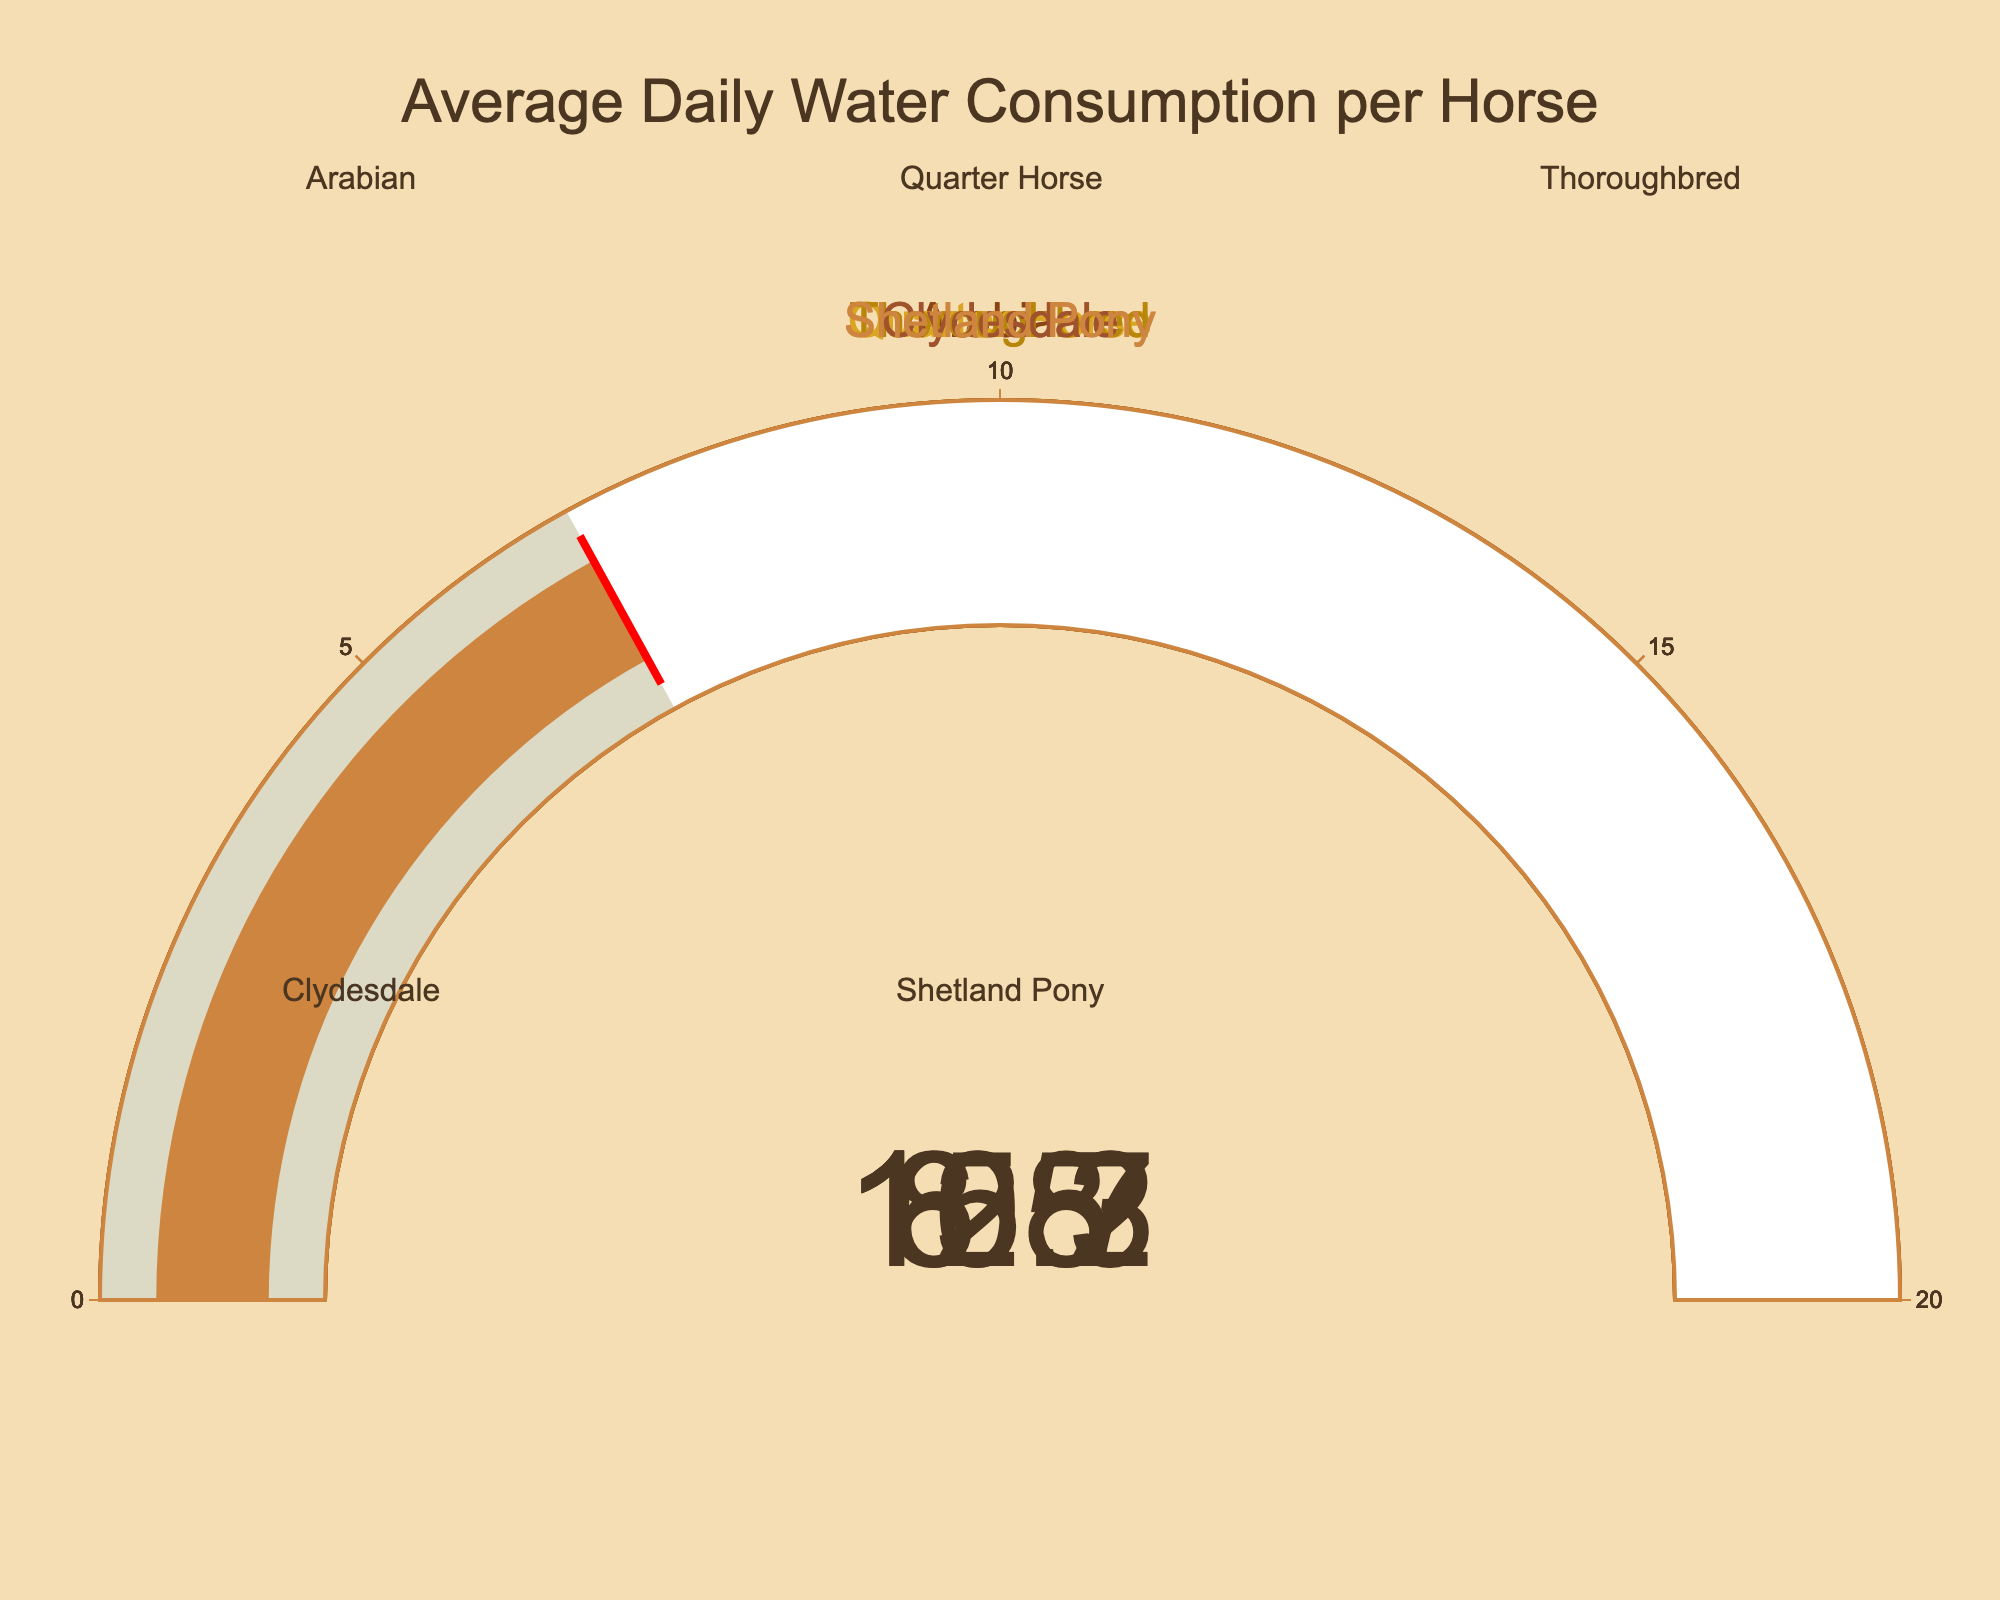What is the title of the figure? The title is displayed at the top of the figure. It reads "Average Daily Water Consumption per Horse".
Answer: Average Daily Water Consumption per Horse How many types of horses are represented? There are 5 dials on the figure, each representing a different type of horse: Arabian, Quarter Horse, Thoroughbred, Clydesdale, and Shetland Pony.
Answer: 5 What is the average daily water consumption for an Arabian horse? Looking at the dial corresponding to the Arabian horse, it shows a consumption value of 8.5 gallons.
Answer: 8.5 gallons Which horse has the highest average daily water consumption? The figure displays different water consumption levels for each horse. The higher value is 15.3 gallons, associated with the Clydesdale.
Answer: Clydesdale What is the total average daily water consumption of all the horses combined? To find the total, sum the individual consumptions: 8.5 + 10.2 + 12.7 + 15.3 + 6.8 = 53.5 gallons.
Answer: 53.5 gallons Which horse consumes more water daily, the Quarter Horse or the Shetland Pony? Comparing the dials, the Quarter Horse shows 10.2 gallons, while the Shetland Pony shows 6.8 gallons. The Quarter Horse consumes more.
Answer: Quarter Horse What is the range of water consumption displayed on the dials? The dials have an axis range from 0 to 20 gallons, as seen from the gauge markings.
Answer: 0 to 20 gallons How much more water does the Thoroughbred consume compared to the Arabian? Thoroughbred's consumption is 12.7 gallons and Arabian's is 8.5 gallons. The difference is 12.7 - 8.5 = 4.2 gallons.
Answer: 4.2 gallons Which horse has the lowest average daily water consumption? The dial with the lowest value is the one for the Shetland Pony, showing 6.8 gallons.
Answer: Shetland Pony Is the water consumption of the Quarter Horse above or below 10 gallons? The dial for the Quarter Horse points to 10.2 gallons, which is above 10 gallons.
Answer: Above 